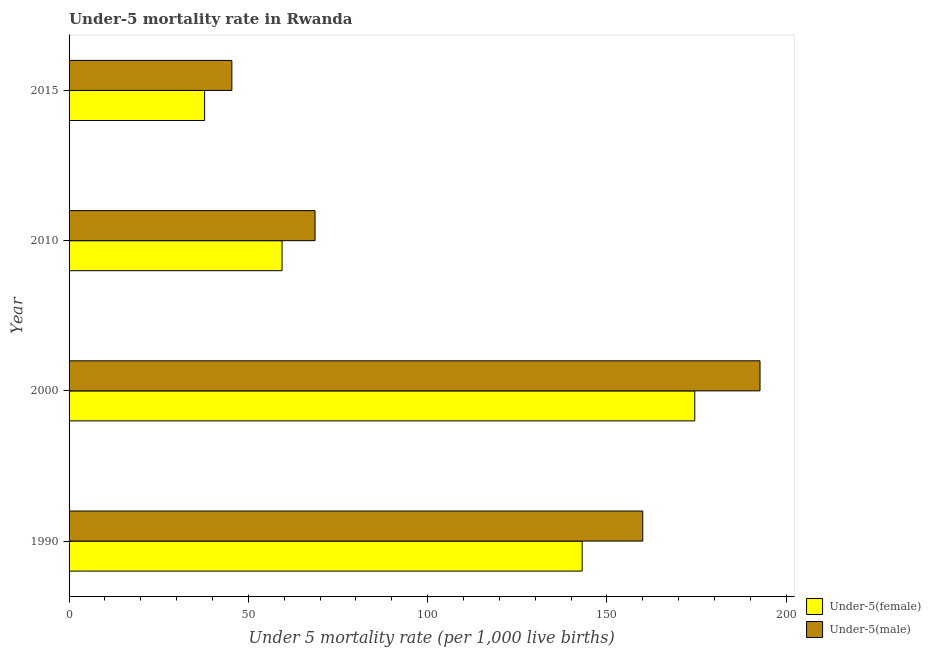Are the number of bars on each tick of the Y-axis equal?
Your answer should be very brief. Yes. How many bars are there on the 4th tick from the top?
Make the answer very short. 2. What is the label of the 1st group of bars from the top?
Provide a succinct answer. 2015. What is the under-5 female mortality rate in 2010?
Ensure brevity in your answer.  59.4. Across all years, what is the maximum under-5 male mortality rate?
Make the answer very short. 192.7. Across all years, what is the minimum under-5 male mortality rate?
Your answer should be very brief. 45.4. In which year was the under-5 female mortality rate minimum?
Your response must be concise. 2015. What is the total under-5 male mortality rate in the graph?
Offer a terse response. 466.7. What is the difference between the under-5 male mortality rate in 1990 and that in 2015?
Keep it short and to the point. 114.6. What is the difference between the under-5 female mortality rate in 1990 and the under-5 male mortality rate in 2000?
Keep it short and to the point. -49.6. What is the average under-5 female mortality rate per year?
Your response must be concise. 103.7. In how many years, is the under-5 male mortality rate greater than 50 ?
Your answer should be very brief. 3. What is the ratio of the under-5 female mortality rate in 1990 to that in 2000?
Make the answer very short. 0.82. Is the under-5 male mortality rate in 2010 less than that in 2015?
Keep it short and to the point. No. Is the difference between the under-5 male mortality rate in 2000 and 2010 greater than the difference between the under-5 female mortality rate in 2000 and 2010?
Keep it short and to the point. Yes. What is the difference between the highest and the second highest under-5 female mortality rate?
Provide a succinct answer. 31.4. What is the difference between the highest and the lowest under-5 male mortality rate?
Ensure brevity in your answer.  147.3. What does the 2nd bar from the top in 2010 represents?
Provide a succinct answer. Under-5(female). What does the 2nd bar from the bottom in 2010 represents?
Provide a succinct answer. Under-5(male). Are the values on the major ticks of X-axis written in scientific E-notation?
Offer a very short reply. No. Does the graph contain any zero values?
Keep it short and to the point. No. Does the graph contain grids?
Offer a terse response. No. How many legend labels are there?
Offer a very short reply. 2. What is the title of the graph?
Your response must be concise. Under-5 mortality rate in Rwanda. What is the label or title of the X-axis?
Offer a very short reply. Under 5 mortality rate (per 1,0 live births). What is the label or title of the Y-axis?
Make the answer very short. Year. What is the Under 5 mortality rate (per 1,000 live births) in Under-5(female) in 1990?
Provide a short and direct response. 143.1. What is the Under 5 mortality rate (per 1,000 live births) of Under-5(male) in 1990?
Give a very brief answer. 160. What is the Under 5 mortality rate (per 1,000 live births) in Under-5(female) in 2000?
Offer a very short reply. 174.5. What is the Under 5 mortality rate (per 1,000 live births) in Under-5(male) in 2000?
Your answer should be compact. 192.7. What is the Under 5 mortality rate (per 1,000 live births) of Under-5(female) in 2010?
Keep it short and to the point. 59.4. What is the Under 5 mortality rate (per 1,000 live births) of Under-5(male) in 2010?
Make the answer very short. 68.6. What is the Under 5 mortality rate (per 1,000 live births) of Under-5(female) in 2015?
Make the answer very short. 37.8. What is the Under 5 mortality rate (per 1,000 live births) of Under-5(male) in 2015?
Your answer should be compact. 45.4. Across all years, what is the maximum Under 5 mortality rate (per 1,000 live births) of Under-5(female)?
Your answer should be compact. 174.5. Across all years, what is the maximum Under 5 mortality rate (per 1,000 live births) in Under-5(male)?
Keep it short and to the point. 192.7. Across all years, what is the minimum Under 5 mortality rate (per 1,000 live births) in Under-5(female)?
Offer a terse response. 37.8. Across all years, what is the minimum Under 5 mortality rate (per 1,000 live births) of Under-5(male)?
Your response must be concise. 45.4. What is the total Under 5 mortality rate (per 1,000 live births) of Under-5(female) in the graph?
Your answer should be compact. 414.8. What is the total Under 5 mortality rate (per 1,000 live births) of Under-5(male) in the graph?
Offer a terse response. 466.7. What is the difference between the Under 5 mortality rate (per 1,000 live births) of Under-5(female) in 1990 and that in 2000?
Offer a very short reply. -31.4. What is the difference between the Under 5 mortality rate (per 1,000 live births) of Under-5(male) in 1990 and that in 2000?
Make the answer very short. -32.7. What is the difference between the Under 5 mortality rate (per 1,000 live births) of Under-5(female) in 1990 and that in 2010?
Ensure brevity in your answer.  83.7. What is the difference between the Under 5 mortality rate (per 1,000 live births) in Under-5(male) in 1990 and that in 2010?
Offer a terse response. 91.4. What is the difference between the Under 5 mortality rate (per 1,000 live births) in Under-5(female) in 1990 and that in 2015?
Ensure brevity in your answer.  105.3. What is the difference between the Under 5 mortality rate (per 1,000 live births) of Under-5(male) in 1990 and that in 2015?
Provide a short and direct response. 114.6. What is the difference between the Under 5 mortality rate (per 1,000 live births) in Under-5(female) in 2000 and that in 2010?
Offer a terse response. 115.1. What is the difference between the Under 5 mortality rate (per 1,000 live births) of Under-5(male) in 2000 and that in 2010?
Your response must be concise. 124.1. What is the difference between the Under 5 mortality rate (per 1,000 live births) of Under-5(female) in 2000 and that in 2015?
Provide a succinct answer. 136.7. What is the difference between the Under 5 mortality rate (per 1,000 live births) in Under-5(male) in 2000 and that in 2015?
Your answer should be compact. 147.3. What is the difference between the Under 5 mortality rate (per 1,000 live births) of Under-5(female) in 2010 and that in 2015?
Your answer should be very brief. 21.6. What is the difference between the Under 5 mortality rate (per 1,000 live births) in Under-5(male) in 2010 and that in 2015?
Your response must be concise. 23.2. What is the difference between the Under 5 mortality rate (per 1,000 live births) of Under-5(female) in 1990 and the Under 5 mortality rate (per 1,000 live births) of Under-5(male) in 2000?
Provide a succinct answer. -49.6. What is the difference between the Under 5 mortality rate (per 1,000 live births) of Under-5(female) in 1990 and the Under 5 mortality rate (per 1,000 live births) of Under-5(male) in 2010?
Give a very brief answer. 74.5. What is the difference between the Under 5 mortality rate (per 1,000 live births) in Under-5(female) in 1990 and the Under 5 mortality rate (per 1,000 live births) in Under-5(male) in 2015?
Make the answer very short. 97.7. What is the difference between the Under 5 mortality rate (per 1,000 live births) in Under-5(female) in 2000 and the Under 5 mortality rate (per 1,000 live births) in Under-5(male) in 2010?
Ensure brevity in your answer.  105.9. What is the difference between the Under 5 mortality rate (per 1,000 live births) of Under-5(female) in 2000 and the Under 5 mortality rate (per 1,000 live births) of Under-5(male) in 2015?
Offer a very short reply. 129.1. What is the difference between the Under 5 mortality rate (per 1,000 live births) of Under-5(female) in 2010 and the Under 5 mortality rate (per 1,000 live births) of Under-5(male) in 2015?
Provide a succinct answer. 14. What is the average Under 5 mortality rate (per 1,000 live births) of Under-5(female) per year?
Ensure brevity in your answer.  103.7. What is the average Under 5 mortality rate (per 1,000 live births) in Under-5(male) per year?
Provide a succinct answer. 116.67. In the year 1990, what is the difference between the Under 5 mortality rate (per 1,000 live births) in Under-5(female) and Under 5 mortality rate (per 1,000 live births) in Under-5(male)?
Keep it short and to the point. -16.9. In the year 2000, what is the difference between the Under 5 mortality rate (per 1,000 live births) in Under-5(female) and Under 5 mortality rate (per 1,000 live births) in Under-5(male)?
Your response must be concise. -18.2. In the year 2010, what is the difference between the Under 5 mortality rate (per 1,000 live births) of Under-5(female) and Under 5 mortality rate (per 1,000 live births) of Under-5(male)?
Keep it short and to the point. -9.2. In the year 2015, what is the difference between the Under 5 mortality rate (per 1,000 live births) of Under-5(female) and Under 5 mortality rate (per 1,000 live births) of Under-5(male)?
Your answer should be very brief. -7.6. What is the ratio of the Under 5 mortality rate (per 1,000 live births) of Under-5(female) in 1990 to that in 2000?
Your answer should be very brief. 0.82. What is the ratio of the Under 5 mortality rate (per 1,000 live births) of Under-5(male) in 1990 to that in 2000?
Offer a terse response. 0.83. What is the ratio of the Under 5 mortality rate (per 1,000 live births) in Under-5(female) in 1990 to that in 2010?
Make the answer very short. 2.41. What is the ratio of the Under 5 mortality rate (per 1,000 live births) in Under-5(male) in 1990 to that in 2010?
Give a very brief answer. 2.33. What is the ratio of the Under 5 mortality rate (per 1,000 live births) of Under-5(female) in 1990 to that in 2015?
Give a very brief answer. 3.79. What is the ratio of the Under 5 mortality rate (per 1,000 live births) of Under-5(male) in 1990 to that in 2015?
Offer a very short reply. 3.52. What is the ratio of the Under 5 mortality rate (per 1,000 live births) in Under-5(female) in 2000 to that in 2010?
Offer a terse response. 2.94. What is the ratio of the Under 5 mortality rate (per 1,000 live births) in Under-5(male) in 2000 to that in 2010?
Your answer should be compact. 2.81. What is the ratio of the Under 5 mortality rate (per 1,000 live births) in Under-5(female) in 2000 to that in 2015?
Your response must be concise. 4.62. What is the ratio of the Under 5 mortality rate (per 1,000 live births) of Under-5(male) in 2000 to that in 2015?
Your answer should be very brief. 4.24. What is the ratio of the Under 5 mortality rate (per 1,000 live births) in Under-5(female) in 2010 to that in 2015?
Offer a very short reply. 1.57. What is the ratio of the Under 5 mortality rate (per 1,000 live births) of Under-5(male) in 2010 to that in 2015?
Ensure brevity in your answer.  1.51. What is the difference between the highest and the second highest Under 5 mortality rate (per 1,000 live births) in Under-5(female)?
Your response must be concise. 31.4. What is the difference between the highest and the second highest Under 5 mortality rate (per 1,000 live births) in Under-5(male)?
Your response must be concise. 32.7. What is the difference between the highest and the lowest Under 5 mortality rate (per 1,000 live births) of Under-5(female)?
Ensure brevity in your answer.  136.7. What is the difference between the highest and the lowest Under 5 mortality rate (per 1,000 live births) in Under-5(male)?
Offer a terse response. 147.3. 